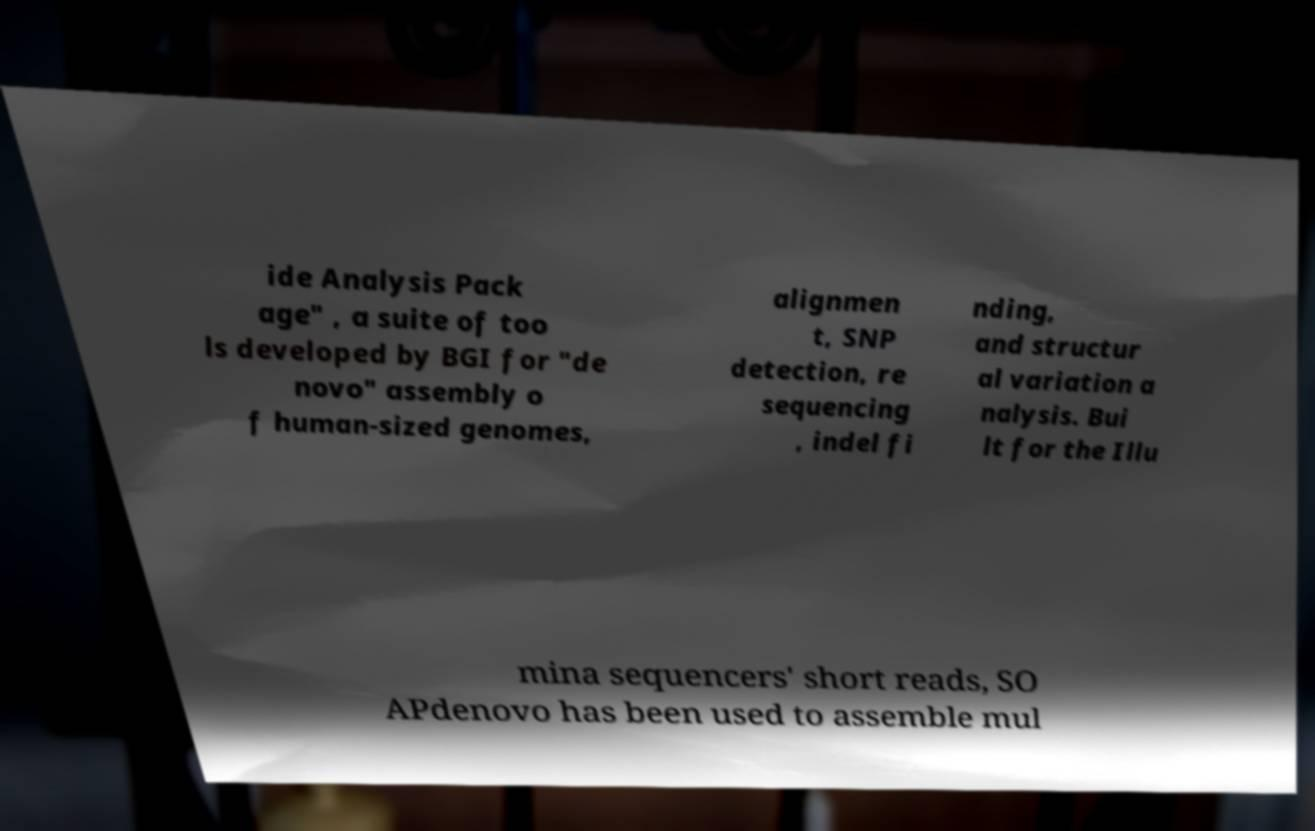I need the written content from this picture converted into text. Can you do that? ide Analysis Pack age" , a suite of too ls developed by BGI for "de novo" assembly o f human-sized genomes, alignmen t, SNP detection, re sequencing , indel fi nding, and structur al variation a nalysis. Bui lt for the Illu mina sequencers' short reads, SO APdenovo has been used to assemble mul 